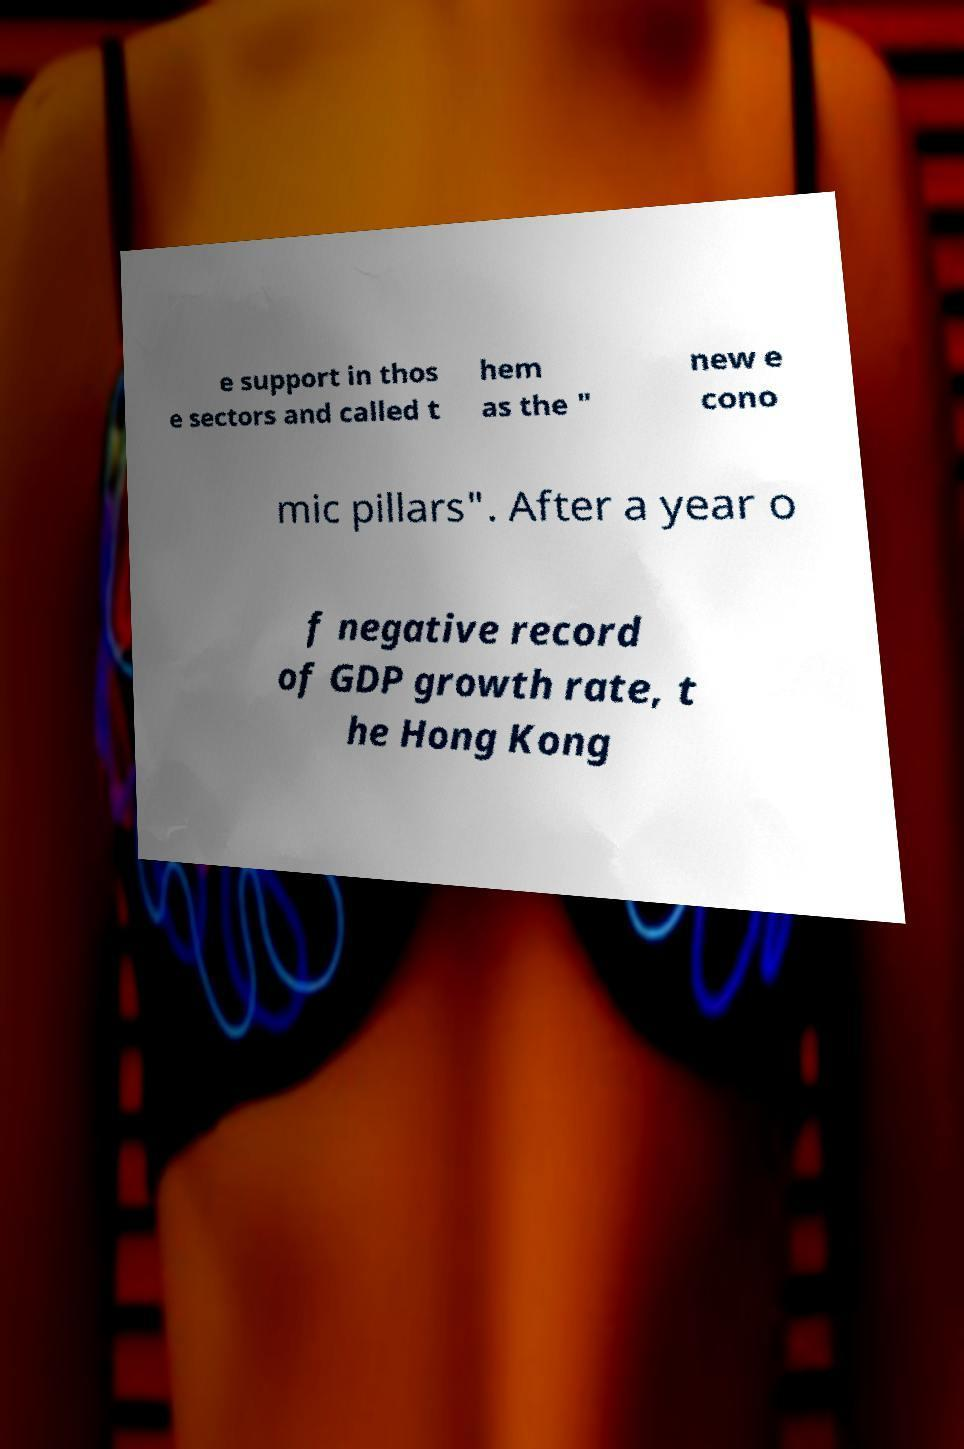What messages or text are displayed in this image? I need them in a readable, typed format. e support in thos e sectors and called t hem as the " new e cono mic pillars". After a year o f negative record of GDP growth rate, t he Hong Kong 